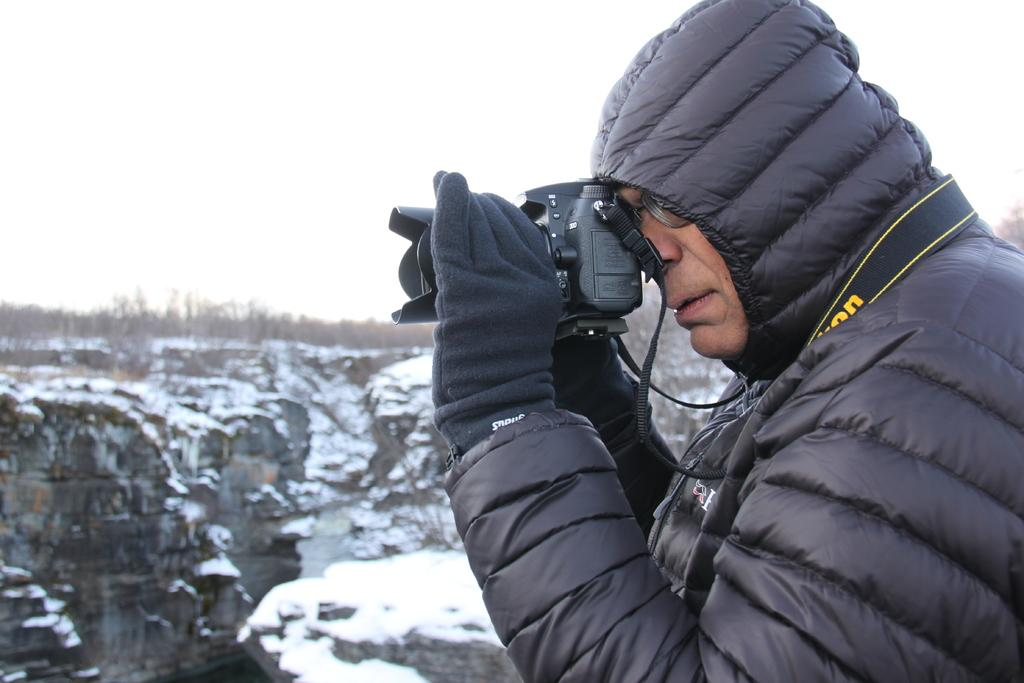What is the main subject of the image? There is a person in the image. What is the person wearing? The person is wearing a black jacket. What is the person doing in the image? The person is taking a picture. What can be seen in the background of the image? There is a camera, the sky, and a hill visible in the background. Can you see the person's parent in the image? There is no parent visible in the image; only the person taking a picture is present. Is the person feeding a goldfish in the image? There is no goldfish present in the image; the person is taking a picture and the background features a camera, the sky, and a hill. 